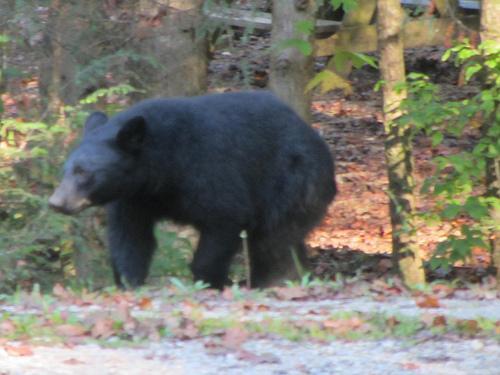How many bears are there?
Give a very brief answer. 1. How many bears are in this photo?
Give a very brief answer. 1. How many of the bears legs are visible?
Give a very brief answer. 3. 